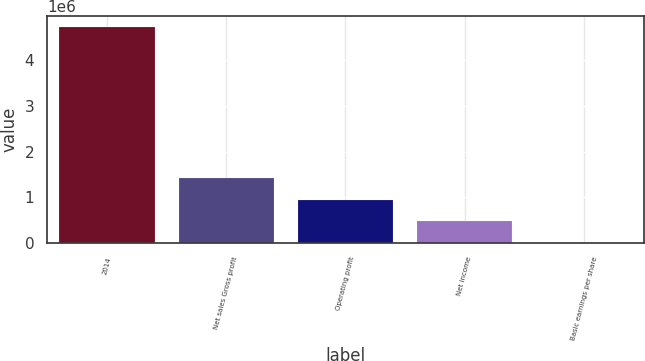Convert chart to OTSL. <chart><loc_0><loc_0><loc_500><loc_500><bar_chart><fcel>2014<fcel>Net sales Gross profit<fcel>Operating profit<fcel>Net income<fcel>Basic earnings per share<nl><fcel>4.72441e+06<fcel>1.42375e+06<fcel>944882<fcel>472442<fcel>0.78<nl></chart> 